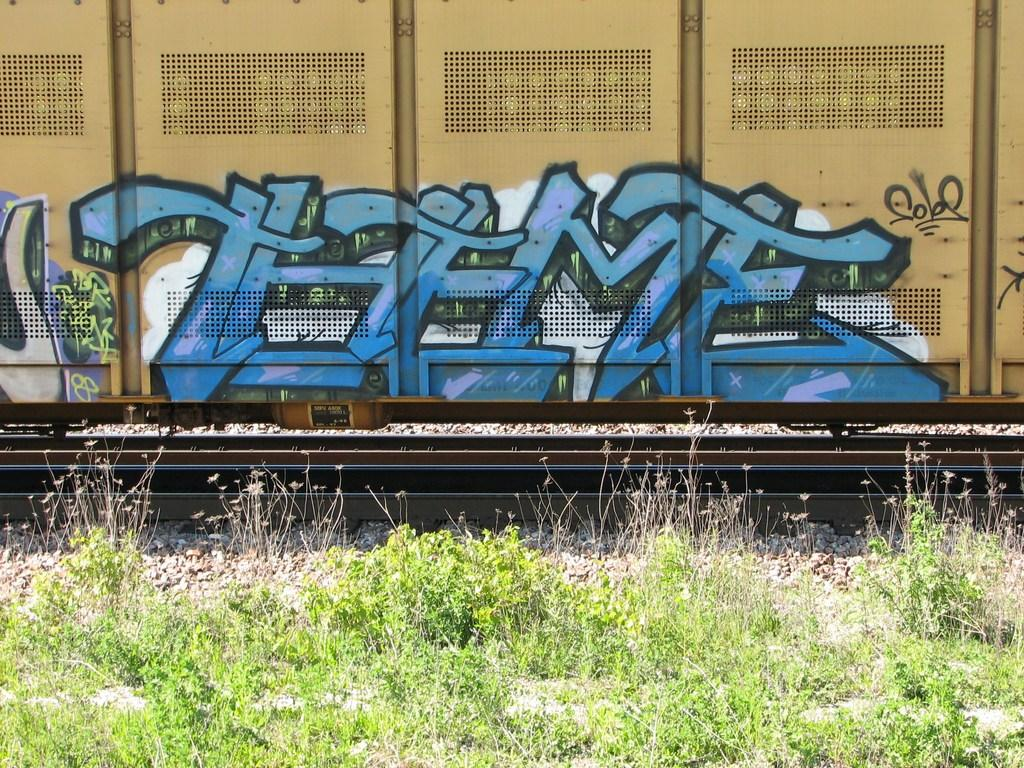Provide a one-sentence caption for the provided image. The train car has graffiti with the letters THFMF on it. 